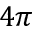Convert formula to latex. <formula><loc_0><loc_0><loc_500><loc_500>4 \pi</formula> 